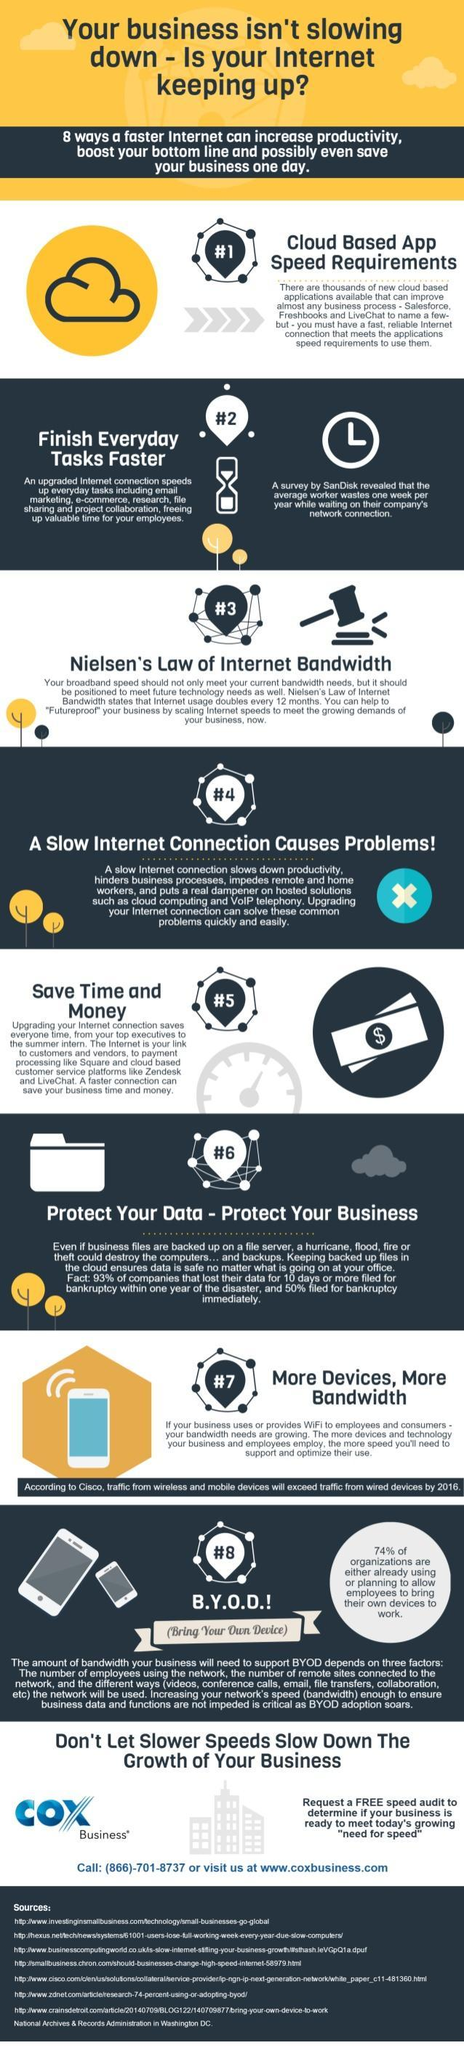Which is the third method to increase the internet bandwidth ?
Answer the question with a short phrase. Nielsen's Law of Internet Bandwidth 